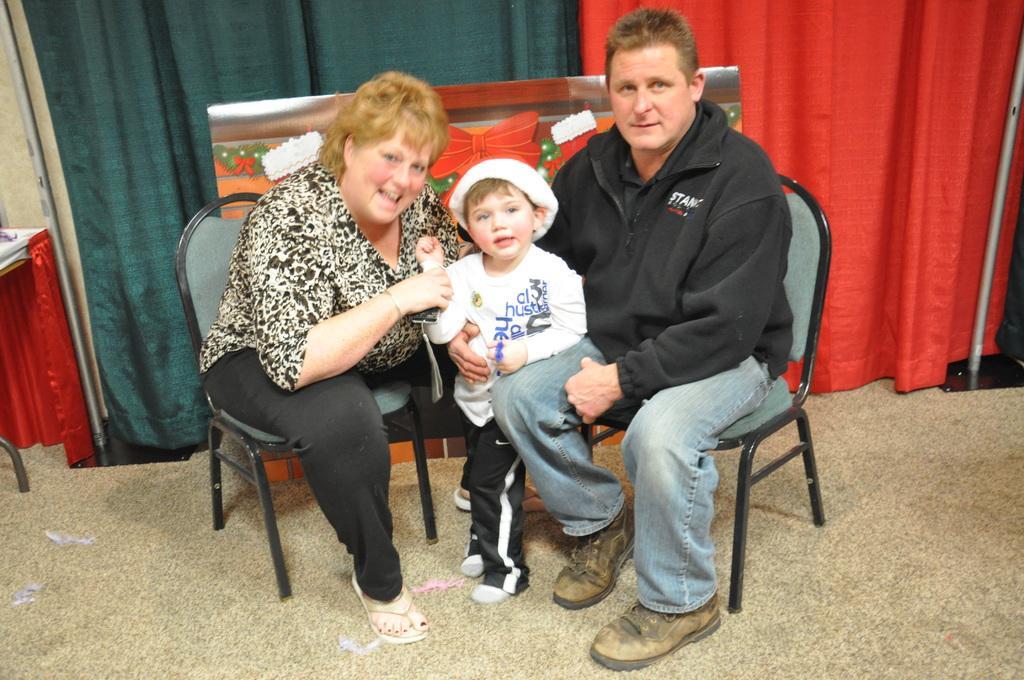Could you give a brief overview of what you see in this image? This picture describes about three people, two people are seated on the chair, one boy is standing between them, in the background we can see metal rods and curtains. 